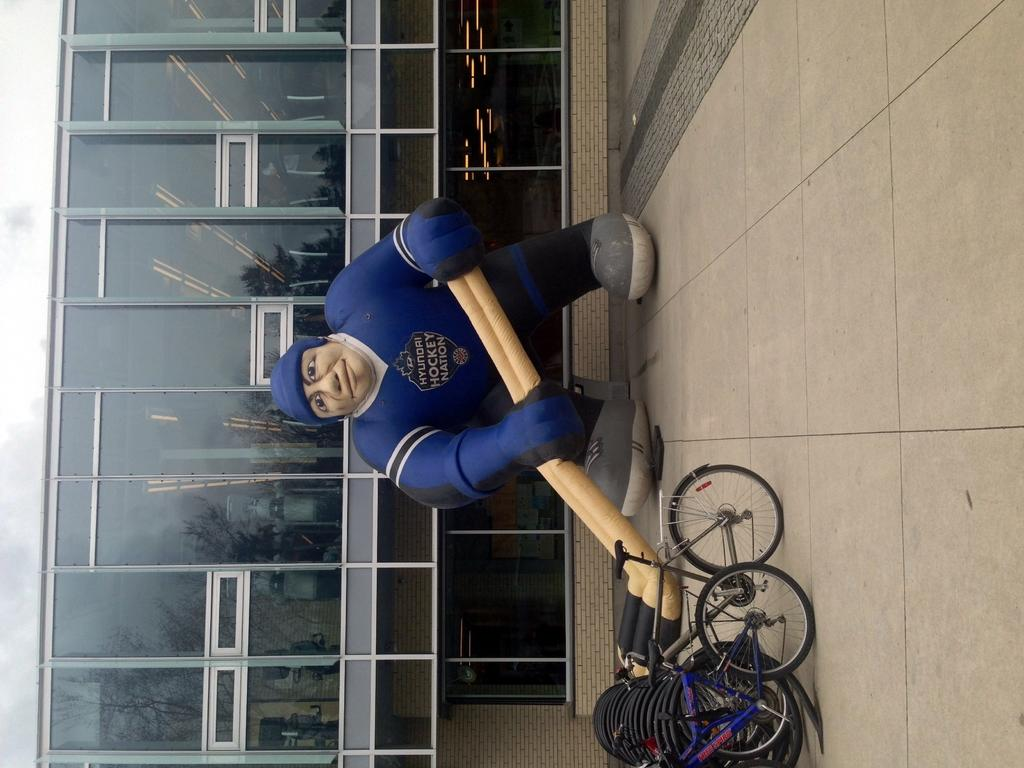What is the main subject of the picture? The main subject of the picture is an air balloon. What else can be seen in the picture besides the air balloon? There are bicycles parked on the side and a building visible in the picture. What type of stocking is hanging from the air balloon in the picture? There is no stocking hanging from the air balloon in the picture. How many bushes are visible near the bicycles in the picture? There is no mention of bushes in the provided facts, so we cannot determine the number of bushes visible near the bicycles. 